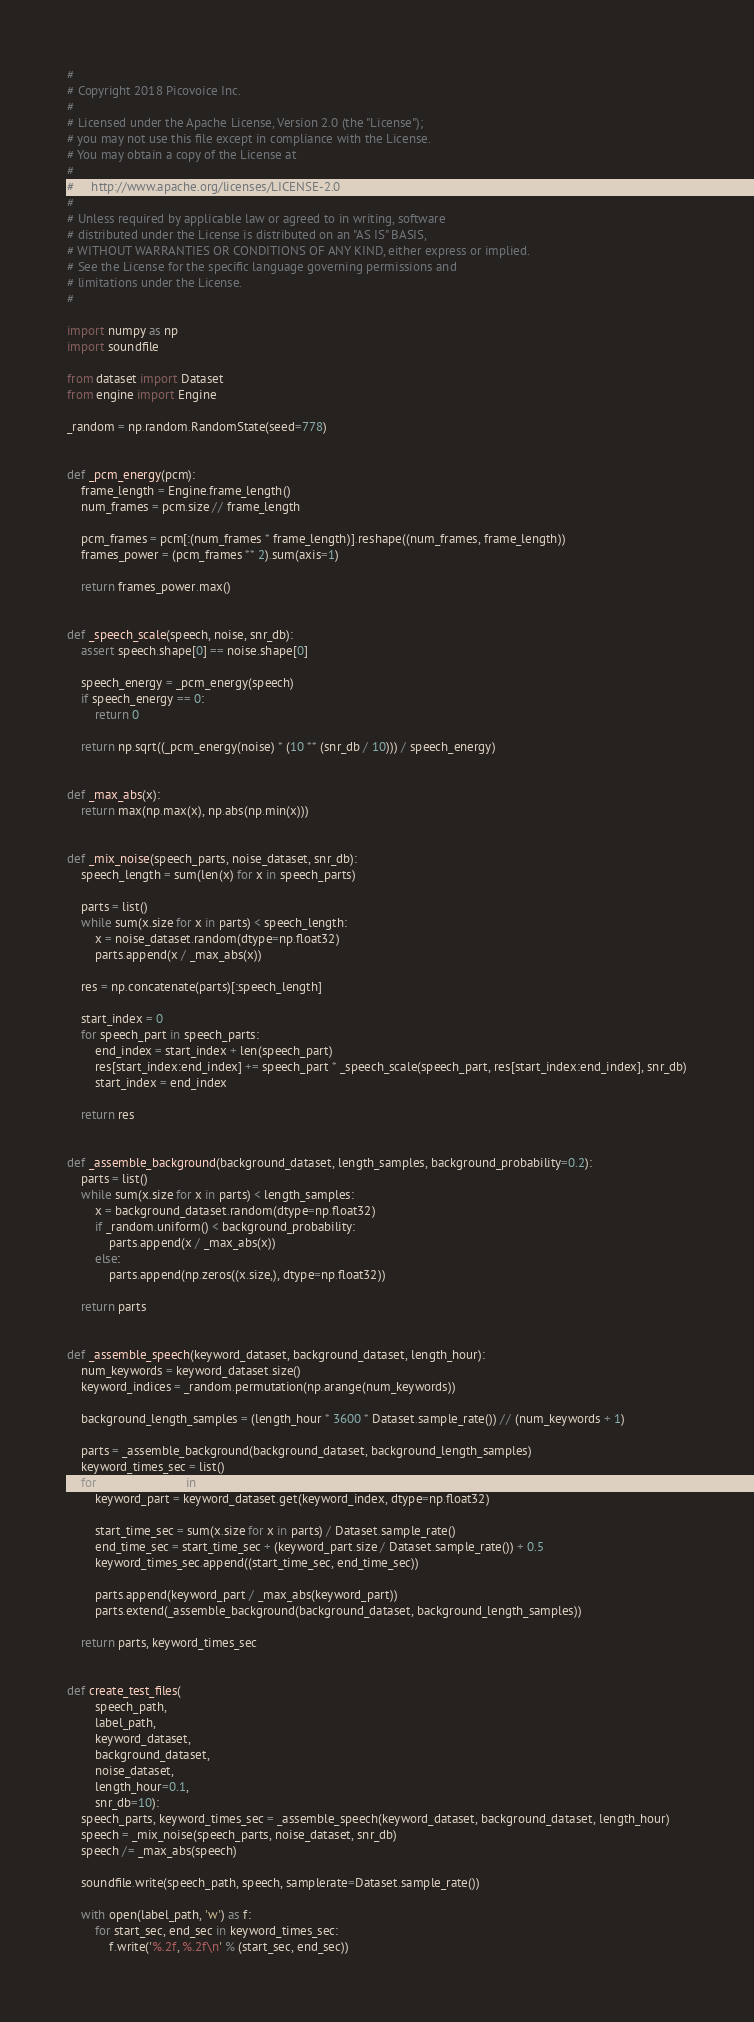<code> <loc_0><loc_0><loc_500><loc_500><_Python_>#
# Copyright 2018 Picovoice Inc.
#
# Licensed under the Apache License, Version 2.0 (the "License");
# you may not use this file except in compliance with the License.
# You may obtain a copy of the License at
#
#     http://www.apache.org/licenses/LICENSE-2.0
#
# Unless required by applicable law or agreed to in writing, software
# distributed under the License is distributed on an "AS IS" BASIS,
# WITHOUT WARRANTIES OR CONDITIONS OF ANY KIND, either express or implied.
# See the License for the specific language governing permissions and
# limitations under the License.
#

import numpy as np
import soundfile

from dataset import Dataset
from engine import Engine

_random = np.random.RandomState(seed=778)


def _pcm_energy(pcm):
    frame_length = Engine.frame_length()
    num_frames = pcm.size // frame_length

    pcm_frames = pcm[:(num_frames * frame_length)].reshape((num_frames, frame_length))
    frames_power = (pcm_frames ** 2).sum(axis=1)

    return frames_power.max()


def _speech_scale(speech, noise, snr_db):
    assert speech.shape[0] == noise.shape[0]

    speech_energy = _pcm_energy(speech)
    if speech_energy == 0:
        return 0

    return np.sqrt((_pcm_energy(noise) * (10 ** (snr_db / 10))) / speech_energy)


def _max_abs(x):
    return max(np.max(x), np.abs(np.min(x)))


def _mix_noise(speech_parts, noise_dataset, snr_db):
    speech_length = sum(len(x) for x in speech_parts)

    parts = list()
    while sum(x.size for x in parts) < speech_length:
        x = noise_dataset.random(dtype=np.float32)
        parts.append(x / _max_abs(x))

    res = np.concatenate(parts)[:speech_length]

    start_index = 0
    for speech_part in speech_parts:
        end_index = start_index + len(speech_part)
        res[start_index:end_index] += speech_part * _speech_scale(speech_part, res[start_index:end_index], snr_db)
        start_index = end_index

    return res


def _assemble_background(background_dataset, length_samples, background_probability=0.2):
    parts = list()
    while sum(x.size for x in parts) < length_samples:
        x = background_dataset.random(dtype=np.float32)
        if _random.uniform() < background_probability:
            parts.append(x / _max_abs(x))
        else:
            parts.append(np.zeros((x.size,), dtype=np.float32))

    return parts


def _assemble_speech(keyword_dataset, background_dataset, length_hour):
    num_keywords = keyword_dataset.size()
    keyword_indices = _random.permutation(np.arange(num_keywords))

    background_length_samples = (length_hour * 3600 * Dataset.sample_rate()) // (num_keywords + 1)

    parts = _assemble_background(background_dataset, background_length_samples)
    keyword_times_sec = list()
    for keyword_index in keyword_indices:
        keyword_part = keyword_dataset.get(keyword_index, dtype=np.float32)

        start_time_sec = sum(x.size for x in parts) / Dataset.sample_rate()
        end_time_sec = start_time_sec + (keyword_part.size / Dataset.sample_rate()) + 0.5
        keyword_times_sec.append((start_time_sec, end_time_sec))

        parts.append(keyword_part / _max_abs(keyword_part))
        parts.extend(_assemble_background(background_dataset, background_length_samples))

    return parts, keyword_times_sec


def create_test_files(
        speech_path,
        label_path,
        keyword_dataset,
        background_dataset,
        noise_dataset,
        length_hour=0.1,
        snr_db=10):
    speech_parts, keyword_times_sec = _assemble_speech(keyword_dataset, background_dataset, length_hour)
    speech = _mix_noise(speech_parts, noise_dataset, snr_db)
    speech /= _max_abs(speech)

    soundfile.write(speech_path, speech, samplerate=Dataset.sample_rate())

    with open(label_path, 'w') as f:
        for start_sec, end_sec in keyword_times_sec:
            f.write('%.2f, %.2f\n' % (start_sec, end_sec))
</code> 